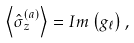<formula> <loc_0><loc_0><loc_500><loc_500>\left < \hat { \sigma } _ { z } ^ { ( a ) } \right > = I m \left ( g _ { \ell } \right ) ,</formula> 